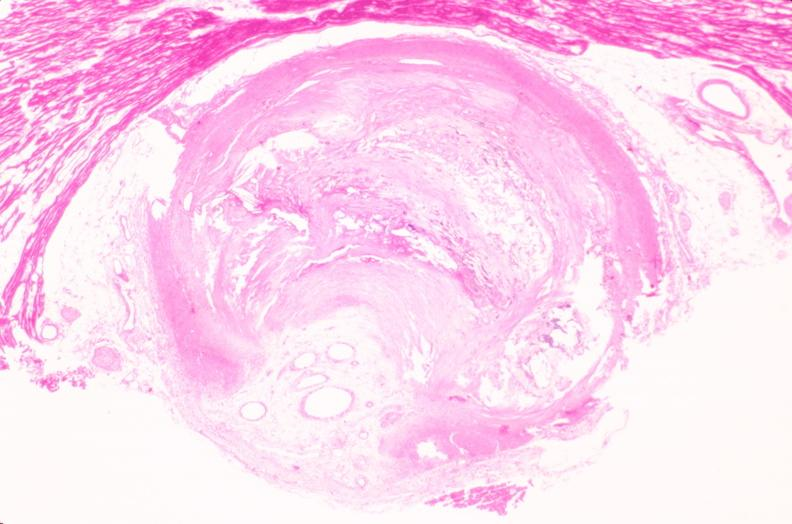where is this in?
Answer the question using a single word or phrase. In vasculature 